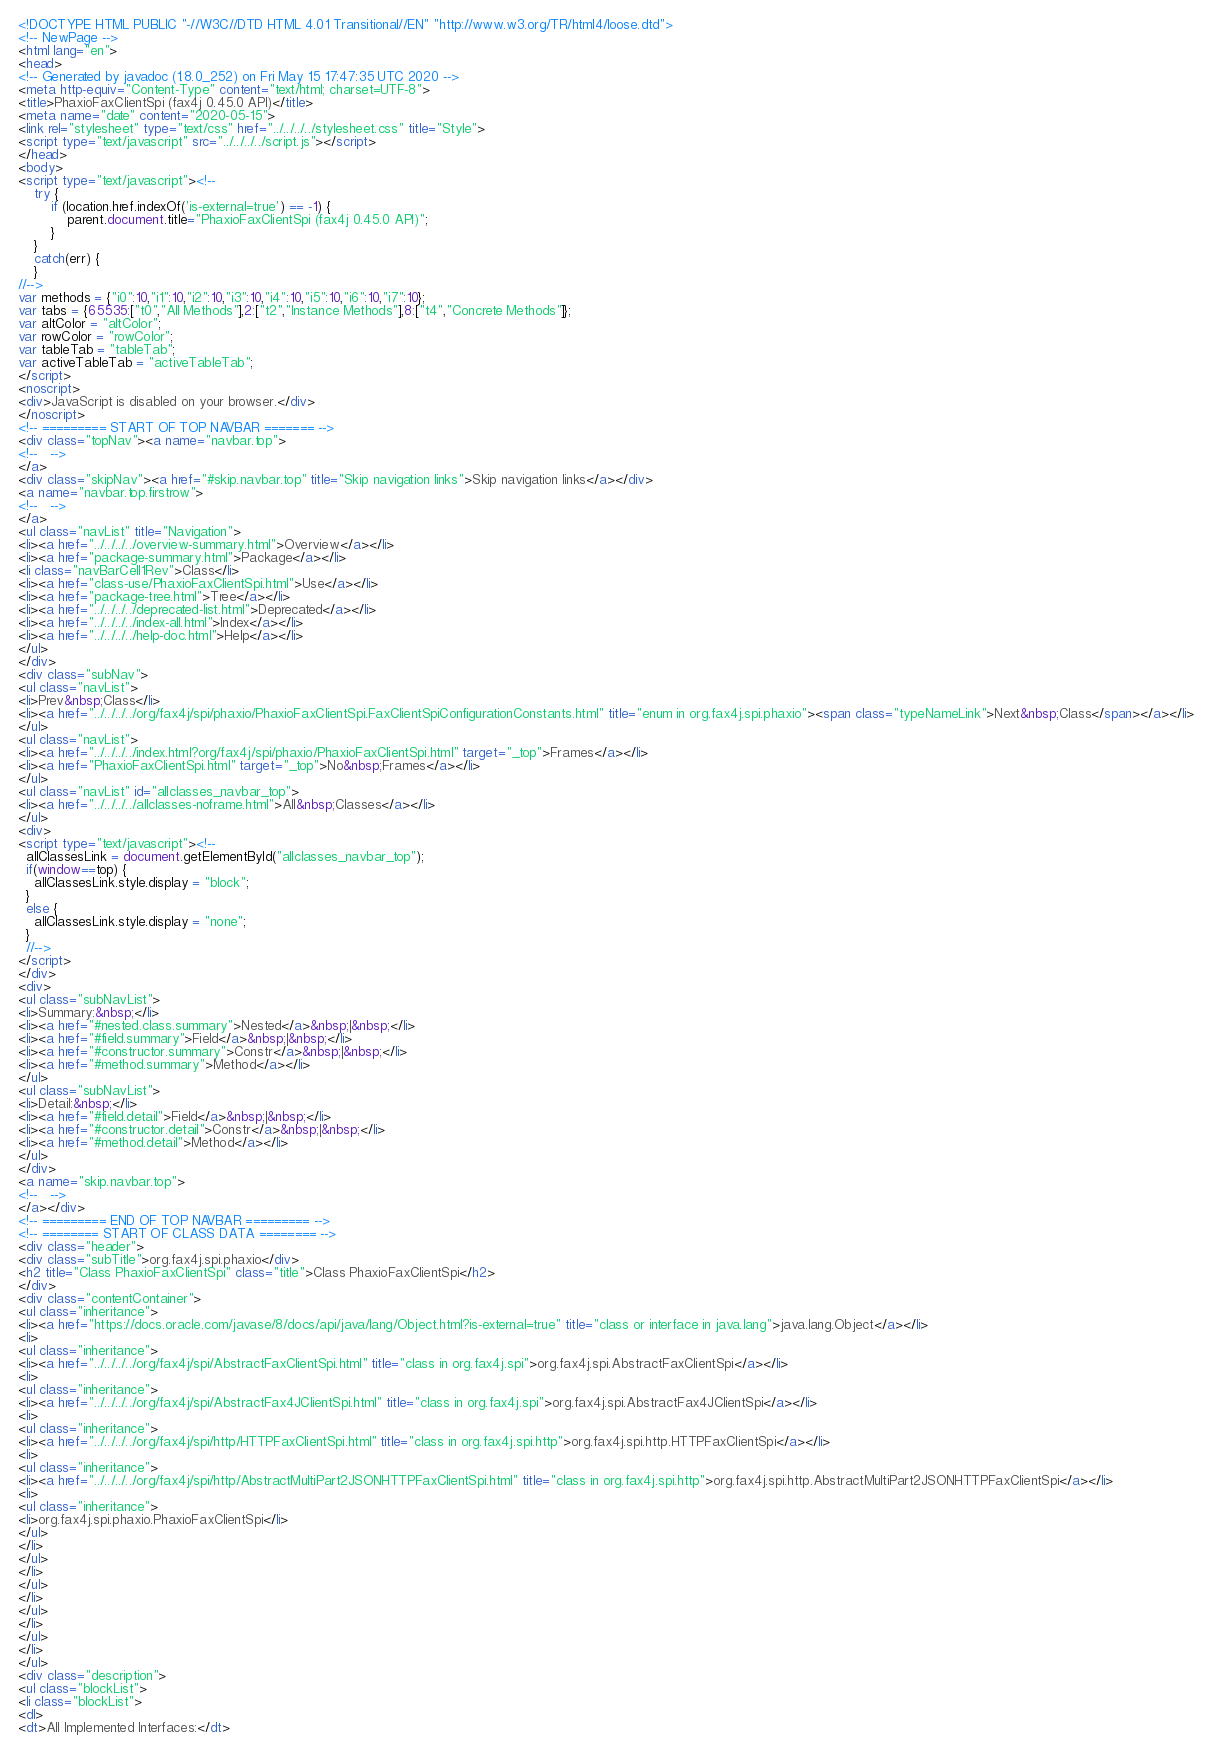Convert code to text. <code><loc_0><loc_0><loc_500><loc_500><_HTML_><!DOCTYPE HTML PUBLIC "-//W3C//DTD HTML 4.01 Transitional//EN" "http://www.w3.org/TR/html4/loose.dtd">
<!-- NewPage -->
<html lang="en">
<head>
<!-- Generated by javadoc (1.8.0_252) on Fri May 15 17:47:35 UTC 2020 -->
<meta http-equiv="Content-Type" content="text/html; charset=UTF-8">
<title>PhaxioFaxClientSpi (fax4j 0.45.0 API)</title>
<meta name="date" content="2020-05-15">
<link rel="stylesheet" type="text/css" href="../../../../stylesheet.css" title="Style">
<script type="text/javascript" src="../../../../script.js"></script>
</head>
<body>
<script type="text/javascript"><!--
    try {
        if (location.href.indexOf('is-external=true') == -1) {
            parent.document.title="PhaxioFaxClientSpi (fax4j 0.45.0 API)";
        }
    }
    catch(err) {
    }
//-->
var methods = {"i0":10,"i1":10,"i2":10,"i3":10,"i4":10,"i5":10,"i6":10,"i7":10};
var tabs = {65535:["t0","All Methods"],2:["t2","Instance Methods"],8:["t4","Concrete Methods"]};
var altColor = "altColor";
var rowColor = "rowColor";
var tableTab = "tableTab";
var activeTableTab = "activeTableTab";
</script>
<noscript>
<div>JavaScript is disabled on your browser.</div>
</noscript>
<!-- ========= START OF TOP NAVBAR ======= -->
<div class="topNav"><a name="navbar.top">
<!--   -->
</a>
<div class="skipNav"><a href="#skip.navbar.top" title="Skip navigation links">Skip navigation links</a></div>
<a name="navbar.top.firstrow">
<!--   -->
</a>
<ul class="navList" title="Navigation">
<li><a href="../../../../overview-summary.html">Overview</a></li>
<li><a href="package-summary.html">Package</a></li>
<li class="navBarCell1Rev">Class</li>
<li><a href="class-use/PhaxioFaxClientSpi.html">Use</a></li>
<li><a href="package-tree.html">Tree</a></li>
<li><a href="../../../../deprecated-list.html">Deprecated</a></li>
<li><a href="../../../../index-all.html">Index</a></li>
<li><a href="../../../../help-doc.html">Help</a></li>
</ul>
</div>
<div class="subNav">
<ul class="navList">
<li>Prev&nbsp;Class</li>
<li><a href="../../../../org/fax4j/spi/phaxio/PhaxioFaxClientSpi.FaxClientSpiConfigurationConstants.html" title="enum in org.fax4j.spi.phaxio"><span class="typeNameLink">Next&nbsp;Class</span></a></li>
</ul>
<ul class="navList">
<li><a href="../../../../index.html?org/fax4j/spi/phaxio/PhaxioFaxClientSpi.html" target="_top">Frames</a></li>
<li><a href="PhaxioFaxClientSpi.html" target="_top">No&nbsp;Frames</a></li>
</ul>
<ul class="navList" id="allclasses_navbar_top">
<li><a href="../../../../allclasses-noframe.html">All&nbsp;Classes</a></li>
</ul>
<div>
<script type="text/javascript"><!--
  allClassesLink = document.getElementById("allclasses_navbar_top");
  if(window==top) {
    allClassesLink.style.display = "block";
  }
  else {
    allClassesLink.style.display = "none";
  }
  //-->
</script>
</div>
<div>
<ul class="subNavList">
<li>Summary:&nbsp;</li>
<li><a href="#nested.class.summary">Nested</a>&nbsp;|&nbsp;</li>
<li><a href="#field.summary">Field</a>&nbsp;|&nbsp;</li>
<li><a href="#constructor.summary">Constr</a>&nbsp;|&nbsp;</li>
<li><a href="#method.summary">Method</a></li>
</ul>
<ul class="subNavList">
<li>Detail:&nbsp;</li>
<li><a href="#field.detail">Field</a>&nbsp;|&nbsp;</li>
<li><a href="#constructor.detail">Constr</a>&nbsp;|&nbsp;</li>
<li><a href="#method.detail">Method</a></li>
</ul>
</div>
<a name="skip.navbar.top">
<!--   -->
</a></div>
<!-- ========= END OF TOP NAVBAR ========= -->
<!-- ======== START OF CLASS DATA ======== -->
<div class="header">
<div class="subTitle">org.fax4j.spi.phaxio</div>
<h2 title="Class PhaxioFaxClientSpi" class="title">Class PhaxioFaxClientSpi</h2>
</div>
<div class="contentContainer">
<ul class="inheritance">
<li><a href="https://docs.oracle.com/javase/8/docs/api/java/lang/Object.html?is-external=true" title="class or interface in java.lang">java.lang.Object</a></li>
<li>
<ul class="inheritance">
<li><a href="../../../../org/fax4j/spi/AbstractFaxClientSpi.html" title="class in org.fax4j.spi">org.fax4j.spi.AbstractFaxClientSpi</a></li>
<li>
<ul class="inheritance">
<li><a href="../../../../org/fax4j/spi/AbstractFax4JClientSpi.html" title="class in org.fax4j.spi">org.fax4j.spi.AbstractFax4JClientSpi</a></li>
<li>
<ul class="inheritance">
<li><a href="../../../../org/fax4j/spi/http/HTTPFaxClientSpi.html" title="class in org.fax4j.spi.http">org.fax4j.spi.http.HTTPFaxClientSpi</a></li>
<li>
<ul class="inheritance">
<li><a href="../../../../org/fax4j/spi/http/AbstractMultiPart2JSONHTTPFaxClientSpi.html" title="class in org.fax4j.spi.http">org.fax4j.spi.http.AbstractMultiPart2JSONHTTPFaxClientSpi</a></li>
<li>
<ul class="inheritance">
<li>org.fax4j.spi.phaxio.PhaxioFaxClientSpi</li>
</ul>
</li>
</ul>
</li>
</ul>
</li>
</ul>
</li>
</ul>
</li>
</ul>
<div class="description">
<ul class="blockList">
<li class="blockList">
<dl>
<dt>All Implemented Interfaces:</dt></code> 